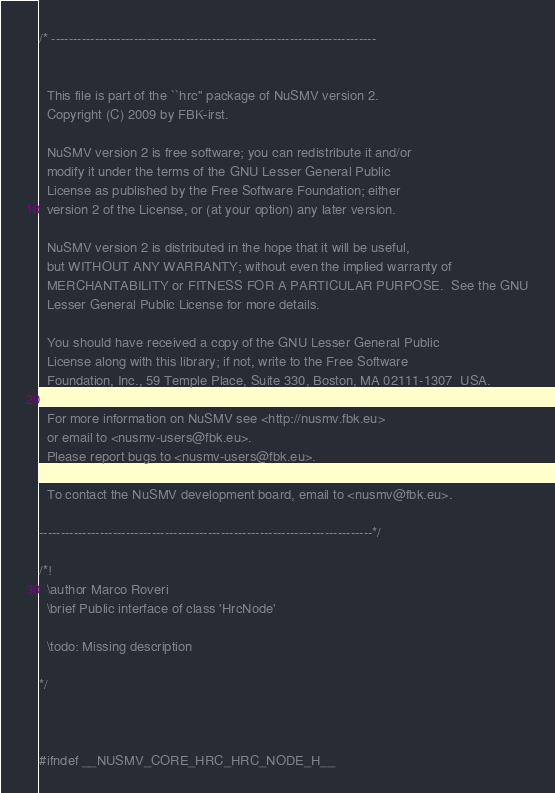<code> <loc_0><loc_0><loc_500><loc_500><_C_>/* ---------------------------------------------------------------------------


  This file is part of the ``hrc'' package of NuSMV version 2.
  Copyright (C) 2009 by FBK-irst.

  NuSMV version 2 is free software; you can redistribute it and/or
  modify it under the terms of the GNU Lesser General Public
  License as published by the Free Software Foundation; either
  version 2 of the License, or (at your option) any later version.

  NuSMV version 2 is distributed in the hope that it will be useful,
  but WITHOUT ANY WARRANTY; without even the implied warranty of
  MERCHANTABILITY or FITNESS FOR A PARTICULAR PURPOSE.  See the GNU
  Lesser General Public License for more details.

  You should have received a copy of the GNU Lesser General Public
  License along with this library; if not, write to the Free Software
  Foundation, Inc., 59 Temple Place, Suite 330, Boston, MA 02111-1307  USA.

  For more information on NuSMV see <http://nusmv.fbk.eu>
  or email to <nusmv-users@fbk.eu>.
  Please report bugs to <nusmv-users@fbk.eu>.

  To contact the NuSMV development board, email to <nusmv@fbk.eu>. 

-----------------------------------------------------------------------------*/

/*!
  \author Marco Roveri
  \brief Public interface of class 'HrcNode'

  \todo: Missing description

*/



#ifndef __NUSMV_CORE_HRC_HRC_NODE_H__</code> 